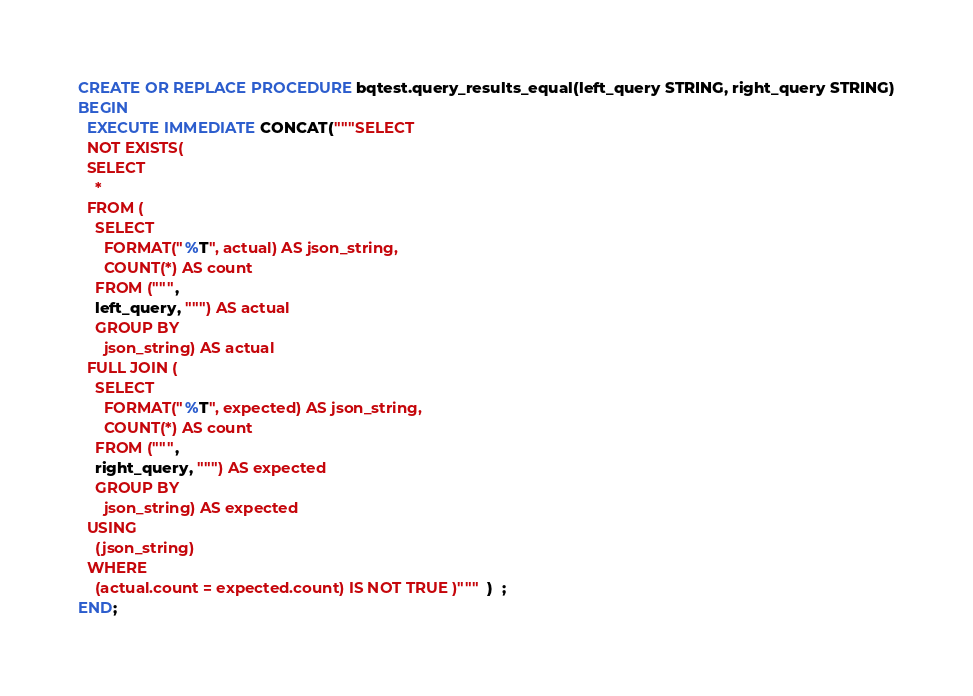<code> <loc_0><loc_0><loc_500><loc_500><_SQL_>CREATE OR REPLACE PROCEDURE bqtest.query_results_equal(left_query STRING, right_query STRING)
BEGIN
  EXECUTE IMMEDIATE CONCAT("""SELECT
  NOT EXISTS(
  SELECT
    *
  FROM (
    SELECT
      FORMAT("%T", actual) AS json_string,
      COUNT(*) AS count
    FROM (""",
    left_query, """) AS actual
    GROUP BY
      json_string) AS actual
  FULL JOIN (
    SELECT
      FORMAT("%T", expected) AS json_string,
      COUNT(*) AS count
    FROM (""",
    right_query, """) AS expected
    GROUP BY
      json_string) AS expected
  USING
    (json_string)
  WHERE
    (actual.count = expected.count) IS NOT TRUE )""")  ;
END;
</code> 